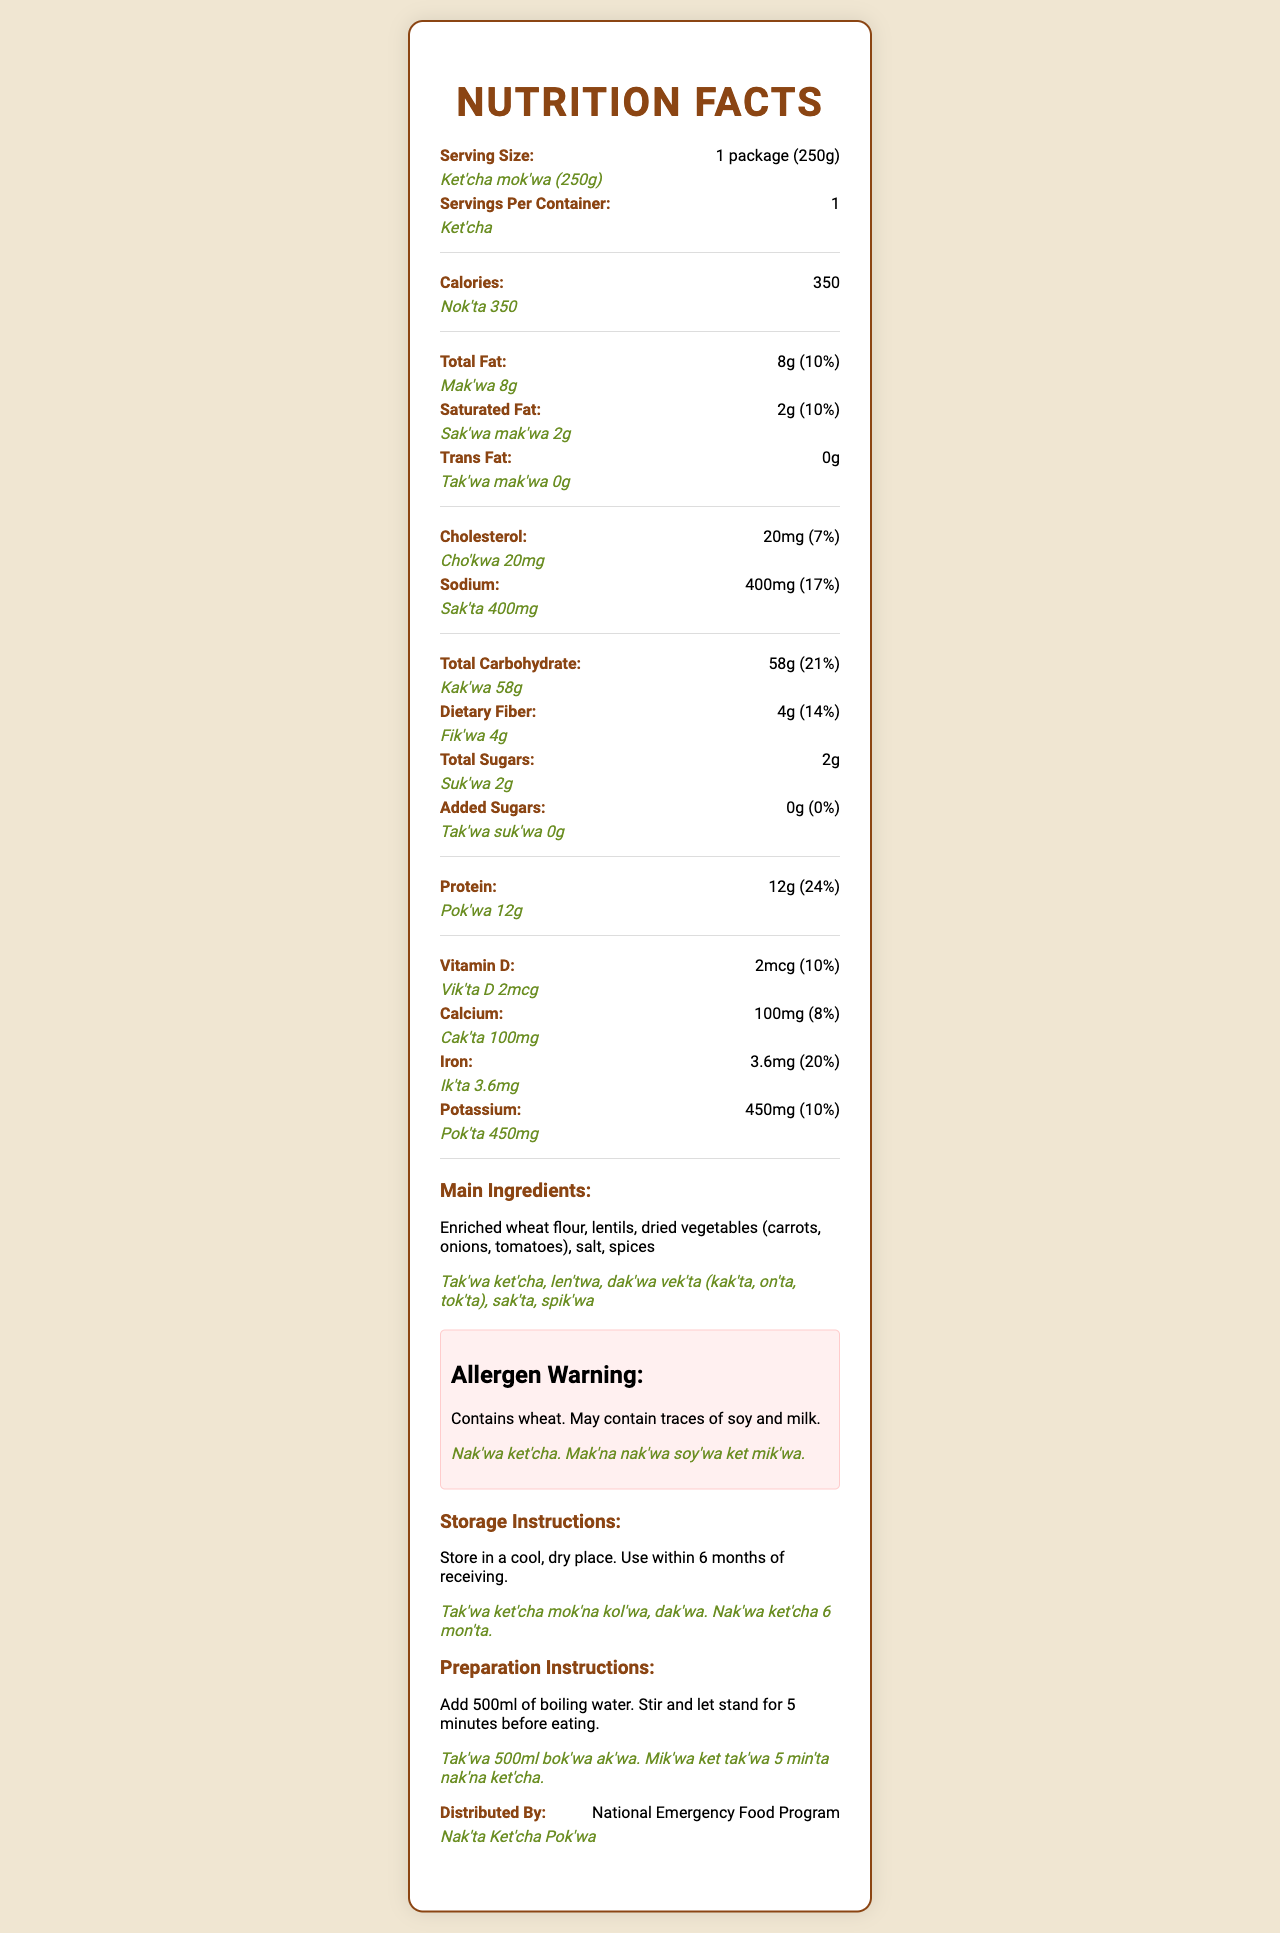what is the serving size in tribal language? The serving size is listed as "Ket'cha mok'wa (250g)" under the serving size section.
Answer: Ket'cha mok'wa (250g) how many calories are in one serving? The calories per serving are listed as 350.
Answer: 350 what is the total fat content in tribal language? The total fat content is given as "Mak'wa 8g" in the tribal language section.
Answer: Mak'wa 8g what are the main ingredients in tribal language? The main ingredients in tribal language are listed as "Tak'wa ket'cha, len'twa, dak'wa vek'ta (kak'ta, on'ta, tok'ta), sak'ta, spik'wa".
Answer: Tak'wa ket'cha, len'twa, dak'wa vek'ta (kak'ta, on'ta, tok'ta), sak'ta, spik'wa how long should the food be allowed to stand after adding boiling water? The preparation instructions state to let the food stand for 5 minutes.
Answer: 5 minutes which nutrient has the highest daily value percentage? A. Sodium B. Protein C. Iron D. Vitamin D Protein has the highest daily value percentage at 24%.
Answer: B. Protein what is the daily value percentage of dietary fiber? A. 14% B. 10% C. 21% D. 17% The daily value percentage for dietary fiber is listed as 14%.
Answer: A. 14% does the product contain any added sugars? The document lists added sugars as 0g with a daily value percentage of 0%.
Answer: No describe the storage instructions in tribal language The storage instructions in tribal language are to store in a cool, dry place and use within 6 months of receiving.
Answer: Tak'wa ket'cha mok'na kol'wa, dak'wa. Nak'wa ket'cha 6 mon'ta does the document provide information on allergens? The allergen warning states "Contains wheat. May contain traces of soy and milk."
Answer: Yes what is the total carbohydrate content in tribal language? The total carbohydrate content is listed as "Kak'wa 58g" in the tribal language.
Answer: Kak'wa 58g who distributes the food rations according to the document? The document states that the food is distributed by the National Emergency Food Program.
Answer: National Emergency Food Program what should you add to the package to prepare the food? The preparation instructions specify to add 500ml of boiling water.
Answer: 500ml of boiling water what is the cholesterol content per serving in tribal language? The cholesterol content per serving is listed as "Cho'kwa 20mg" in the tribal language.
Answer: Cho'kwa 20mg how many servings are there per container? The document states that there is 1 serving per container.
Answer: 1 what percentage of the daily value of calcium does one serving provide? The document lists the daily value percentage for calcium as 8%.
Answer: 8% summarize the main idea of the document The document is a comprehensive nutrition label for government-supplied food rations, detailing serving sizes, nutrient content, and preparation/storage instructions, provided in both English and tribal languages. It also highlights allergen information and main ingredients.
Answer: The document provides detailed nutrition facts and preparation/storage instructions for the government-supplied food rations, including serving size, calorie count, and nutrient content in both English and tribal languages. It also includes allergen warnings, main ingredients, and distributor information. when was the food ration program established? The document does not provide information regarding when the food ration program was established.
Answer: Cannot be determined 